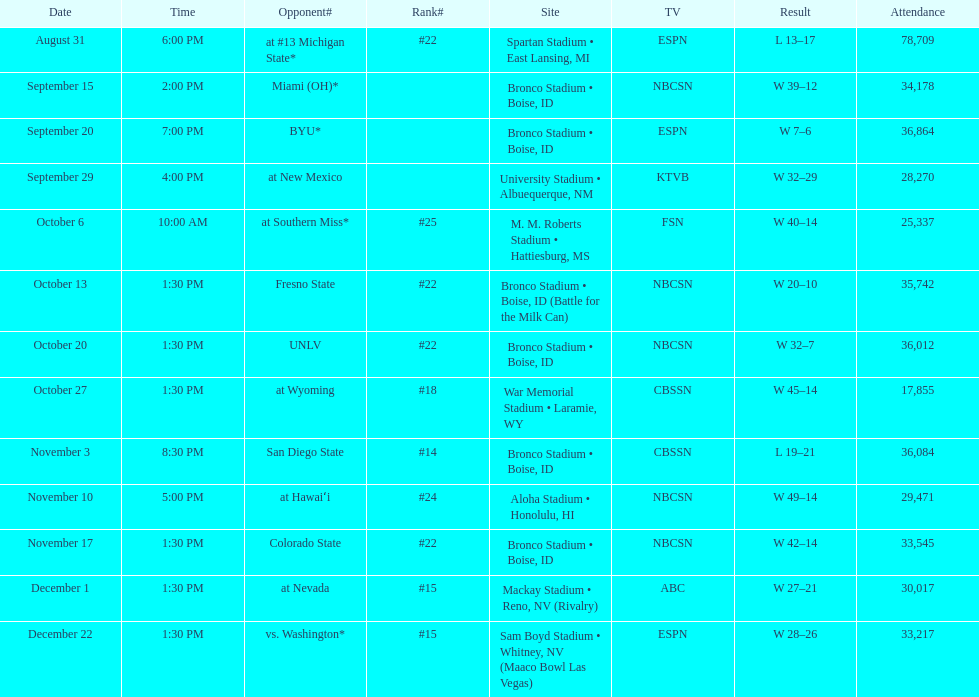Can you parse all the data within this table? {'header': ['Date', 'Time', 'Opponent#', 'Rank#', 'Site', 'TV', 'Result', 'Attendance'], 'rows': [['August 31', '6:00 PM', 'at\xa0#13\xa0Michigan State*', '#22', 'Spartan Stadium • East Lansing, MI', 'ESPN', 'L\xa013–17', '78,709'], ['September 15', '2:00 PM', 'Miami (OH)*', '', 'Bronco Stadium • Boise, ID', 'NBCSN', 'W\xa039–12', '34,178'], ['September 20', '7:00 PM', 'BYU*', '', 'Bronco Stadium • Boise, ID', 'ESPN', 'W\xa07–6', '36,864'], ['September 29', '4:00 PM', 'at\xa0New Mexico', '', 'University Stadium • Albuequerque, NM', 'KTVB', 'W\xa032–29', '28,270'], ['October 6', '10:00 AM', 'at\xa0Southern Miss*', '#25', 'M. M. Roberts Stadium • Hattiesburg, MS', 'FSN', 'W\xa040–14', '25,337'], ['October 13', '1:30 PM', 'Fresno State', '#22', 'Bronco Stadium • Boise, ID (Battle for the Milk Can)', 'NBCSN', 'W\xa020–10', '35,742'], ['October 20', '1:30 PM', 'UNLV', '#22', 'Bronco Stadium • Boise, ID', 'NBCSN', 'W\xa032–7', '36,012'], ['October 27', '1:30 PM', 'at\xa0Wyoming', '#18', 'War Memorial Stadium • Laramie, WY', 'CBSSN', 'W\xa045–14', '17,855'], ['November 3', '8:30 PM', 'San Diego State', '#14', 'Bronco Stadium • Boise, ID', 'CBSSN', 'L\xa019–21', '36,084'], ['November 10', '5:00 PM', 'at\xa0Hawaiʻi', '#24', 'Aloha Stadium • Honolulu, HI', 'NBCSN', 'W\xa049–14', '29,471'], ['November 17', '1:30 PM', 'Colorado State', '#22', 'Bronco Stadium • Boise, ID', 'NBCSN', 'W\xa042–14', '33,545'], ['December 1', '1:30 PM', 'at\xa0Nevada', '#15', 'Mackay Stadium • Reno, NV (Rivalry)', 'ABC', 'W\xa027–21', '30,017'], ['December 22', '1:30 PM', 'vs.\xa0Washington*', '#15', 'Sam Boyd Stadium • Whitney, NV (Maaco Bowl Las Vegas)', 'ESPN', 'W\xa028–26', '33,217']]} Did the broncos on september 29th win by less than 5 points? Yes. 